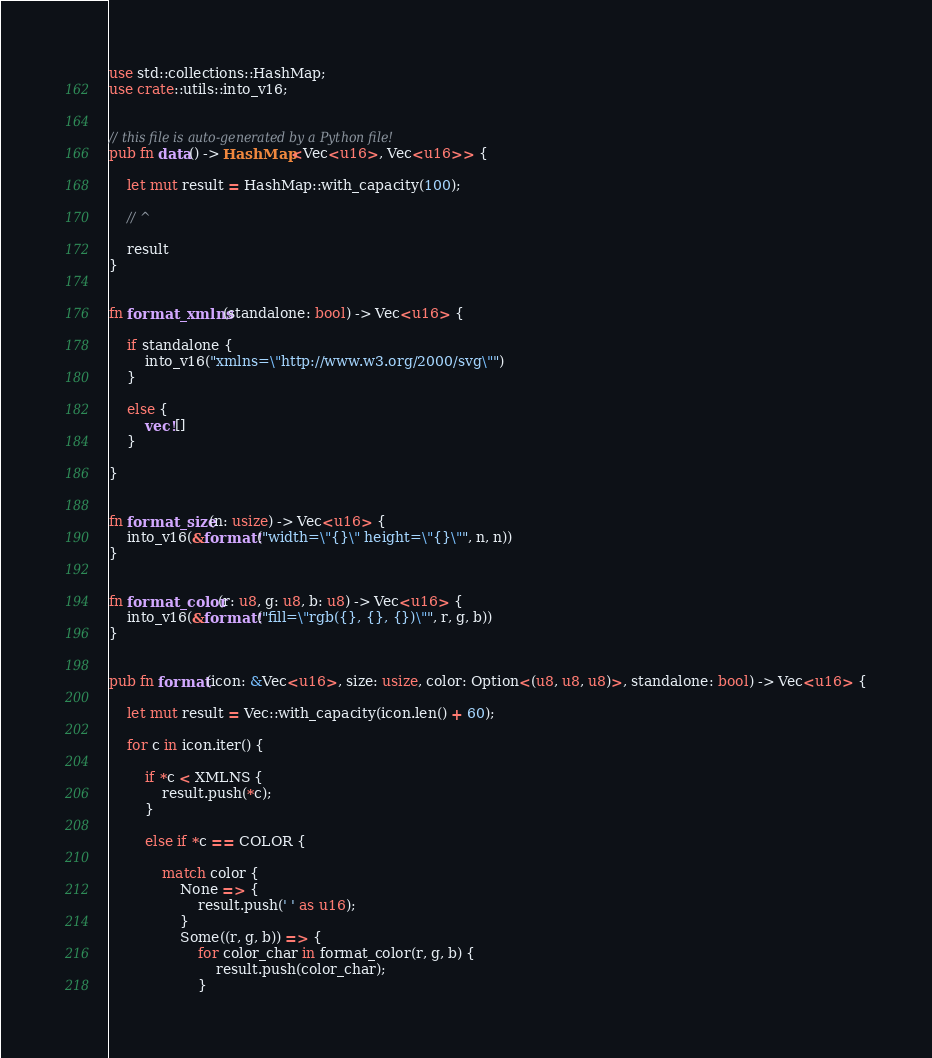Convert code to text. <code><loc_0><loc_0><loc_500><loc_500><_Rust_>use std::collections::HashMap;
use crate::utils::into_v16;


// this file is auto-generated by a Python file!
pub fn data() -> HashMap<Vec<u16>, Vec<u16>> {

    let mut result = HashMap::with_capacity(100);

    // ^

    result
}


fn format_xmlns(standalone: bool) -> Vec<u16> {

    if standalone {
        into_v16("xmlns=\"http://www.w3.org/2000/svg\"")
    }

    else {
        vec![]
    }

}


fn format_size(n: usize) -> Vec<u16> {
    into_v16(&format!("width=\"{}\" height=\"{}\"", n, n))
}


fn format_color(r: u8, g: u8, b: u8) -> Vec<u16> {
    into_v16(&format!("fill=\"rgb({}, {}, {})\"", r, g, b))
}


pub fn format(icon: &Vec<u16>, size: usize, color: Option<(u8, u8, u8)>, standalone: bool) -> Vec<u16> {

    let mut result = Vec::with_capacity(icon.len() + 60);

    for c in icon.iter() {

        if *c < XMLNS {
            result.push(*c);
        }

        else if *c == COLOR {

            match color {
                None => {
                    result.push(' ' as u16);
                }
                Some((r, g, b)) => {
                    for color_char in format_color(r, g, b) {
                        result.push(color_char);
                    }</code> 